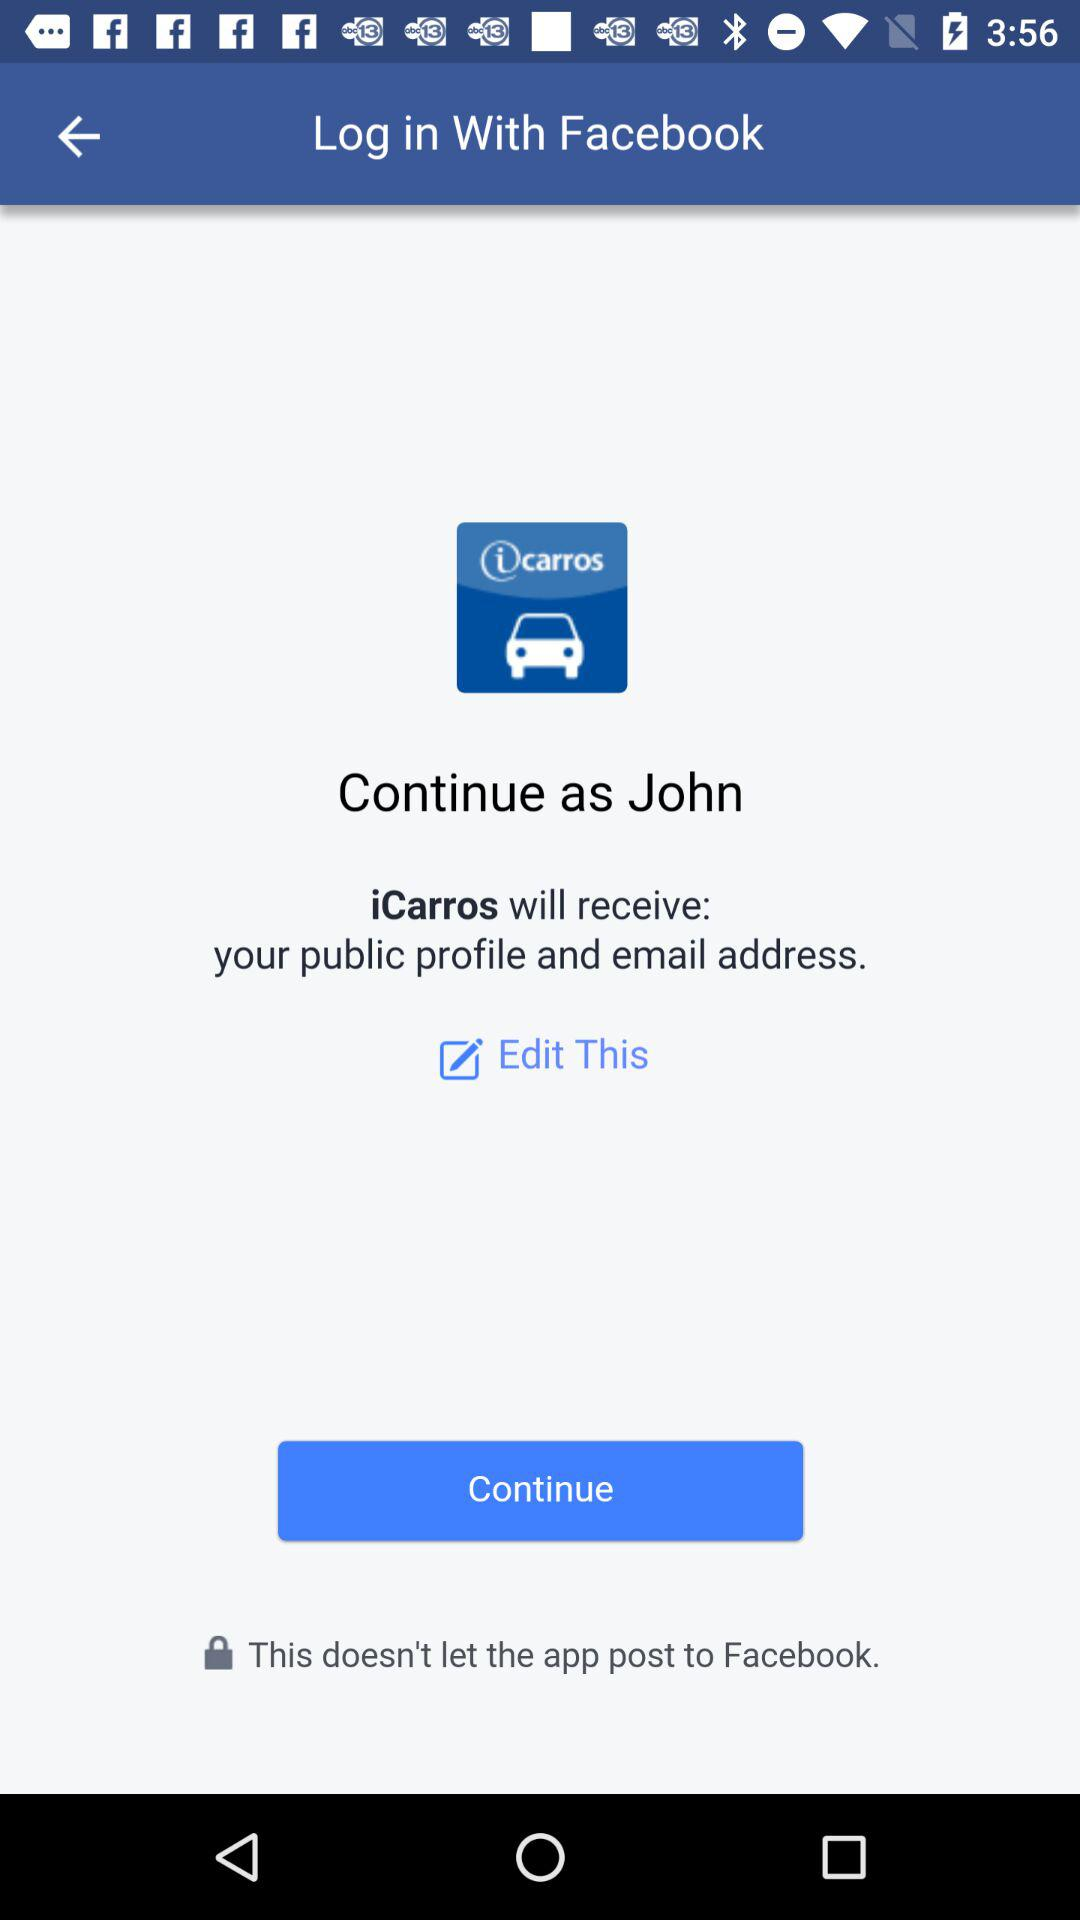What is the name of the user? The name of the user is John. 